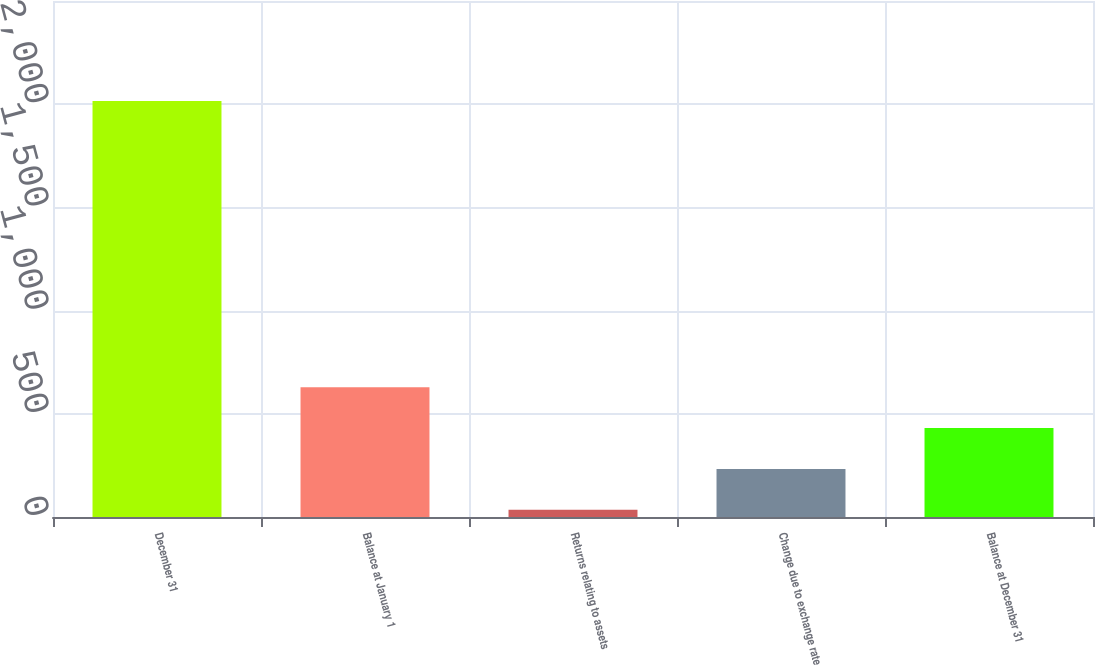Convert chart. <chart><loc_0><loc_0><loc_500><loc_500><bar_chart><fcel>December 31<fcel>Balance at January 1<fcel>Returns relating to assets<fcel>Change due to exchange rate<fcel>Balance at December 31<nl><fcel>2015<fcel>629<fcel>35<fcel>233<fcel>431<nl></chart> 